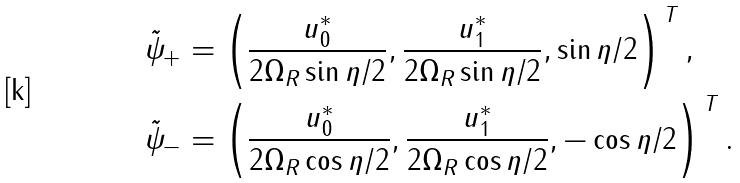<formula> <loc_0><loc_0><loc_500><loc_500>\tilde { \psi } _ { + } & = \left ( \frac { u _ { 0 } ^ { * } } { 2 \Omega _ { R } \sin \eta / 2 } , \frac { u _ { 1 } ^ { * } } { 2 \Omega _ { R } \sin \eta / 2 } , \sin \eta / 2 \right ) ^ { \, T } , \\ \tilde { \psi } _ { - } & = \left ( \frac { u _ { 0 } ^ { * } } { 2 \Omega _ { R } \cos \eta / 2 } , \frac { u _ { 1 } ^ { * } } { 2 \Omega _ { R } \cos \eta / 2 } , - \cos \eta / 2 \right ) ^ { \, T } .</formula> 